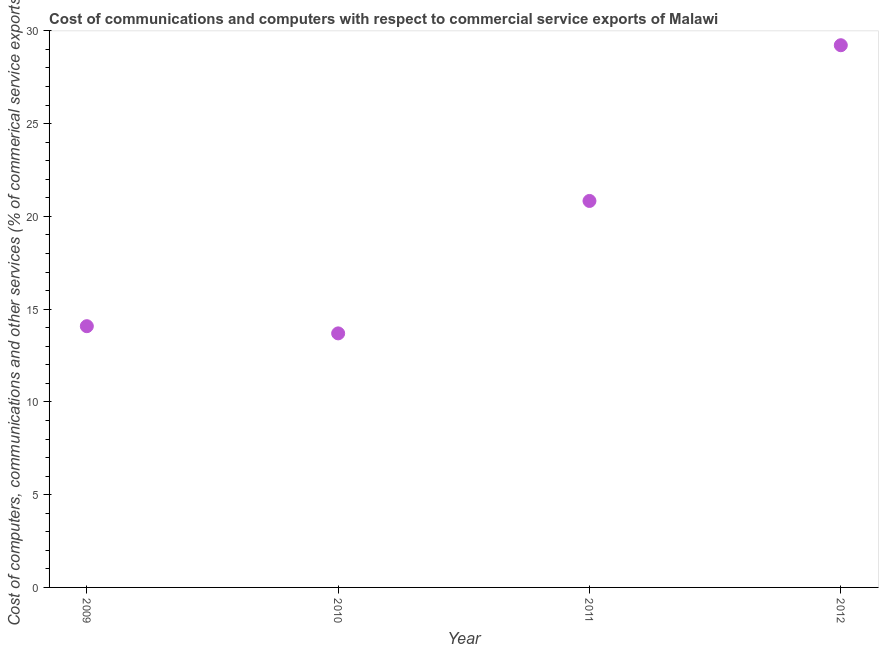What is the cost of communications in 2009?
Keep it short and to the point. 14.08. Across all years, what is the maximum  computer and other services?
Offer a terse response. 29.23. Across all years, what is the minimum cost of communications?
Make the answer very short. 13.69. In which year was the  computer and other services minimum?
Give a very brief answer. 2010. What is the sum of the cost of communications?
Your answer should be compact. 77.83. What is the difference between the cost of communications in 2011 and 2012?
Keep it short and to the point. -8.39. What is the average  computer and other services per year?
Your answer should be very brief. 19.46. What is the median  computer and other services?
Offer a very short reply. 17.46. What is the ratio of the  computer and other services in 2009 to that in 2011?
Give a very brief answer. 0.68. Is the  computer and other services in 2010 less than that in 2012?
Offer a terse response. Yes. What is the difference between the highest and the second highest cost of communications?
Make the answer very short. 8.39. What is the difference between the highest and the lowest  computer and other services?
Keep it short and to the point. 15.53. How many dotlines are there?
Make the answer very short. 1. What is the difference between two consecutive major ticks on the Y-axis?
Your answer should be compact. 5. Are the values on the major ticks of Y-axis written in scientific E-notation?
Provide a succinct answer. No. Does the graph contain any zero values?
Offer a terse response. No. Does the graph contain grids?
Your answer should be very brief. No. What is the title of the graph?
Give a very brief answer. Cost of communications and computers with respect to commercial service exports of Malawi. What is the label or title of the Y-axis?
Ensure brevity in your answer.  Cost of computers, communications and other services (% of commerical service exports). What is the Cost of computers, communications and other services (% of commerical service exports) in 2009?
Offer a very short reply. 14.08. What is the Cost of computers, communications and other services (% of commerical service exports) in 2010?
Keep it short and to the point. 13.69. What is the Cost of computers, communications and other services (% of commerical service exports) in 2011?
Give a very brief answer. 20.83. What is the Cost of computers, communications and other services (% of commerical service exports) in 2012?
Ensure brevity in your answer.  29.23. What is the difference between the Cost of computers, communications and other services (% of commerical service exports) in 2009 and 2010?
Provide a succinct answer. 0.39. What is the difference between the Cost of computers, communications and other services (% of commerical service exports) in 2009 and 2011?
Offer a very short reply. -6.75. What is the difference between the Cost of computers, communications and other services (% of commerical service exports) in 2009 and 2012?
Offer a very short reply. -15.14. What is the difference between the Cost of computers, communications and other services (% of commerical service exports) in 2010 and 2011?
Ensure brevity in your answer.  -7.14. What is the difference between the Cost of computers, communications and other services (% of commerical service exports) in 2010 and 2012?
Provide a succinct answer. -15.53. What is the difference between the Cost of computers, communications and other services (% of commerical service exports) in 2011 and 2012?
Keep it short and to the point. -8.39. What is the ratio of the Cost of computers, communications and other services (% of commerical service exports) in 2009 to that in 2010?
Offer a very short reply. 1.03. What is the ratio of the Cost of computers, communications and other services (% of commerical service exports) in 2009 to that in 2011?
Offer a terse response. 0.68. What is the ratio of the Cost of computers, communications and other services (% of commerical service exports) in 2009 to that in 2012?
Provide a succinct answer. 0.48. What is the ratio of the Cost of computers, communications and other services (% of commerical service exports) in 2010 to that in 2011?
Your answer should be very brief. 0.66. What is the ratio of the Cost of computers, communications and other services (% of commerical service exports) in 2010 to that in 2012?
Ensure brevity in your answer.  0.47. What is the ratio of the Cost of computers, communications and other services (% of commerical service exports) in 2011 to that in 2012?
Your answer should be compact. 0.71. 